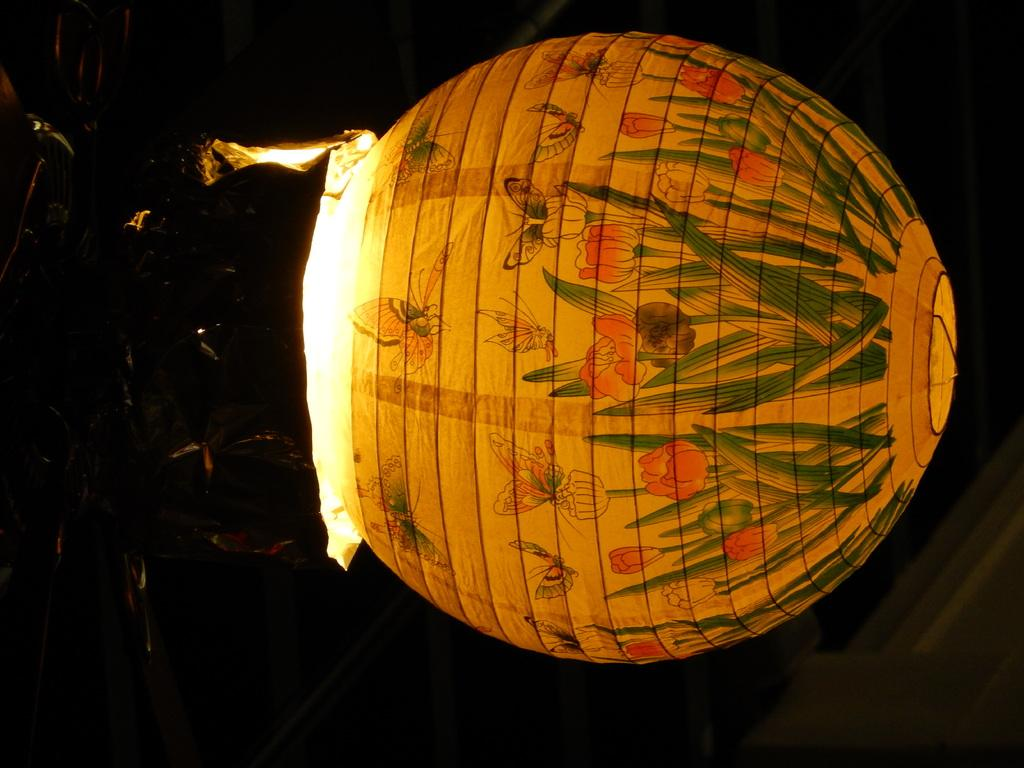What is the main subject of the image? The main subject of the image is a gas balloon. How many kittens are running on bikes in the image? There are no kittens or bikes present in the image; it features a gas balloon. 